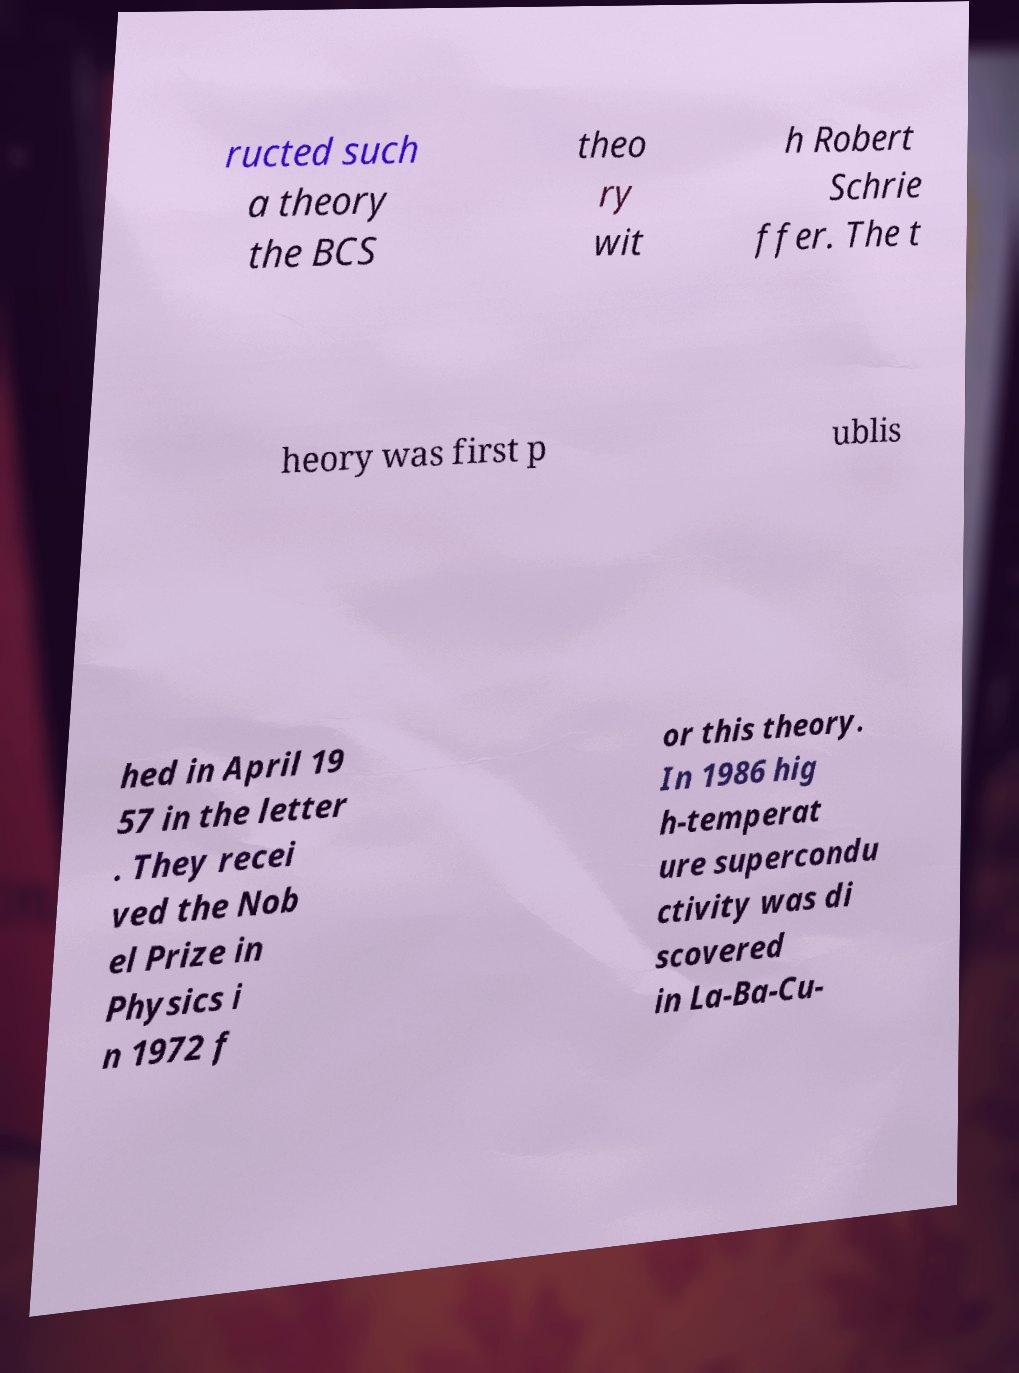I need the written content from this picture converted into text. Can you do that? ructed such a theory the BCS theo ry wit h Robert Schrie ffer. The t heory was first p ublis hed in April 19 57 in the letter . They recei ved the Nob el Prize in Physics i n 1972 f or this theory. In 1986 hig h-temperat ure supercondu ctivity was di scovered in La-Ba-Cu- 